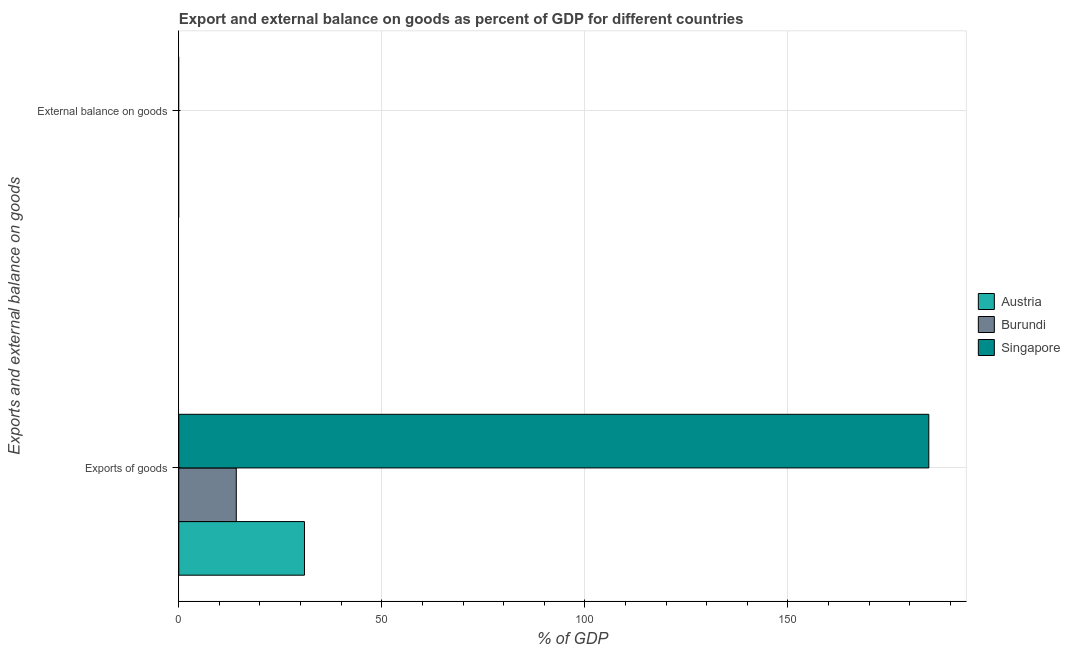How many different coloured bars are there?
Your response must be concise. 3. Are the number of bars per tick equal to the number of legend labels?
Your answer should be very brief. No. How many bars are there on the 1st tick from the bottom?
Make the answer very short. 3. What is the label of the 1st group of bars from the top?
Give a very brief answer. External balance on goods. What is the export of goods as percentage of gdp in Burundi?
Provide a short and direct response. 14.16. Across all countries, what is the maximum export of goods as percentage of gdp?
Provide a short and direct response. 184.72. In which country was the export of goods as percentage of gdp maximum?
Offer a very short reply. Singapore. What is the total export of goods as percentage of gdp in the graph?
Your answer should be compact. 229.84. What is the difference between the export of goods as percentage of gdp in Burundi and that in Austria?
Provide a succinct answer. -16.79. What is the difference between the export of goods as percentage of gdp in Singapore and the external balance on goods as percentage of gdp in Austria?
Offer a terse response. 184.72. What is the average external balance on goods as percentage of gdp per country?
Provide a short and direct response. 0. What is the ratio of the export of goods as percentage of gdp in Austria to that in Singapore?
Ensure brevity in your answer.  0.17. Is the export of goods as percentage of gdp in Burundi less than that in Austria?
Ensure brevity in your answer.  Yes. Are all the bars in the graph horizontal?
Provide a succinct answer. Yes. How many countries are there in the graph?
Your response must be concise. 3. What is the difference between two consecutive major ticks on the X-axis?
Your response must be concise. 50. Are the values on the major ticks of X-axis written in scientific E-notation?
Your response must be concise. No. Does the graph contain any zero values?
Your response must be concise. Yes. Where does the legend appear in the graph?
Make the answer very short. Center right. How are the legend labels stacked?
Keep it short and to the point. Vertical. What is the title of the graph?
Offer a very short reply. Export and external balance on goods as percent of GDP for different countries. Does "Belarus" appear as one of the legend labels in the graph?
Make the answer very short. No. What is the label or title of the X-axis?
Your answer should be very brief. % of GDP. What is the label or title of the Y-axis?
Provide a succinct answer. Exports and external balance on goods. What is the % of GDP of Austria in Exports of goods?
Your answer should be compact. 30.96. What is the % of GDP in Burundi in Exports of goods?
Provide a short and direct response. 14.16. What is the % of GDP of Singapore in Exports of goods?
Your response must be concise. 184.72. What is the % of GDP of Austria in External balance on goods?
Provide a succinct answer. 0. What is the % of GDP in Burundi in External balance on goods?
Give a very brief answer. 0. What is the % of GDP in Singapore in External balance on goods?
Offer a very short reply. 0. Across all Exports and external balance on goods, what is the maximum % of GDP of Austria?
Your answer should be very brief. 30.96. Across all Exports and external balance on goods, what is the maximum % of GDP in Burundi?
Keep it short and to the point. 14.16. Across all Exports and external balance on goods, what is the maximum % of GDP of Singapore?
Keep it short and to the point. 184.72. Across all Exports and external balance on goods, what is the minimum % of GDP in Austria?
Provide a succinct answer. 0. Across all Exports and external balance on goods, what is the minimum % of GDP in Burundi?
Your answer should be compact. 0. Across all Exports and external balance on goods, what is the minimum % of GDP of Singapore?
Keep it short and to the point. 0. What is the total % of GDP of Austria in the graph?
Ensure brevity in your answer.  30.96. What is the total % of GDP of Burundi in the graph?
Offer a very short reply. 14.16. What is the total % of GDP of Singapore in the graph?
Provide a succinct answer. 184.72. What is the average % of GDP of Austria per Exports and external balance on goods?
Keep it short and to the point. 15.48. What is the average % of GDP in Burundi per Exports and external balance on goods?
Your answer should be very brief. 7.08. What is the average % of GDP in Singapore per Exports and external balance on goods?
Offer a very short reply. 92.36. What is the difference between the % of GDP in Austria and % of GDP in Burundi in Exports of goods?
Provide a succinct answer. 16.79. What is the difference between the % of GDP in Austria and % of GDP in Singapore in Exports of goods?
Give a very brief answer. -153.77. What is the difference between the % of GDP in Burundi and % of GDP in Singapore in Exports of goods?
Make the answer very short. -170.56. What is the difference between the highest and the lowest % of GDP in Austria?
Make the answer very short. 30.96. What is the difference between the highest and the lowest % of GDP in Burundi?
Offer a very short reply. 14.16. What is the difference between the highest and the lowest % of GDP in Singapore?
Offer a terse response. 184.72. 